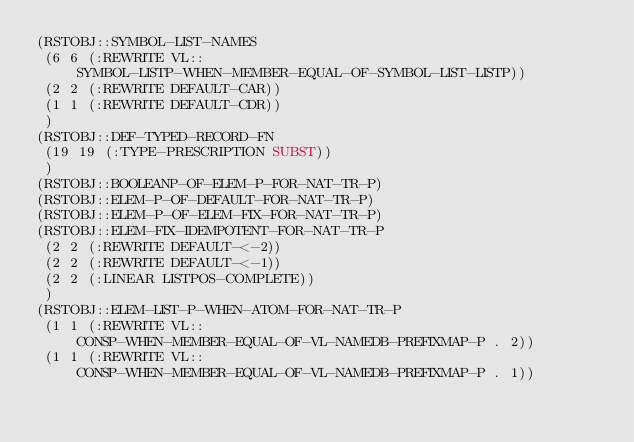Convert code to text. <code><loc_0><loc_0><loc_500><loc_500><_Lisp_>(RSTOBJ::SYMBOL-LIST-NAMES
 (6 6 (:REWRITE VL::SYMBOL-LISTP-WHEN-MEMBER-EQUAL-OF-SYMBOL-LIST-LISTP))
 (2 2 (:REWRITE DEFAULT-CAR))
 (1 1 (:REWRITE DEFAULT-CDR))
 )
(RSTOBJ::DEF-TYPED-RECORD-FN
 (19 19 (:TYPE-PRESCRIPTION SUBST))
 )
(RSTOBJ::BOOLEANP-OF-ELEM-P-FOR-NAT-TR-P)
(RSTOBJ::ELEM-P-OF-DEFAULT-FOR-NAT-TR-P)
(RSTOBJ::ELEM-P-OF-ELEM-FIX-FOR-NAT-TR-P)
(RSTOBJ::ELEM-FIX-IDEMPOTENT-FOR-NAT-TR-P
 (2 2 (:REWRITE DEFAULT-<-2))
 (2 2 (:REWRITE DEFAULT-<-1))
 (2 2 (:LINEAR LISTPOS-COMPLETE))
 )
(RSTOBJ::ELEM-LIST-P-WHEN-ATOM-FOR-NAT-TR-P
 (1 1 (:REWRITE VL::CONSP-WHEN-MEMBER-EQUAL-OF-VL-NAMEDB-PREFIXMAP-P . 2))
 (1 1 (:REWRITE VL::CONSP-WHEN-MEMBER-EQUAL-OF-VL-NAMEDB-PREFIXMAP-P . 1))</code> 